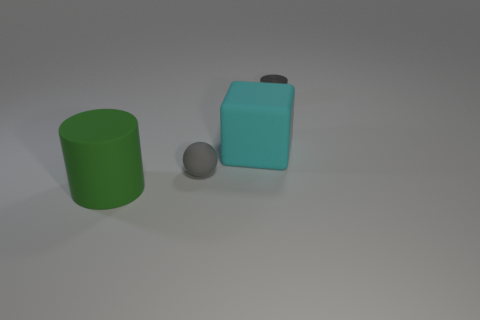There is another large thing that is made of the same material as the green thing; what is its color? The large object made of the same material as the green cylinder is cyan in color, providing a calming aesthetic due to its pastel shade. 